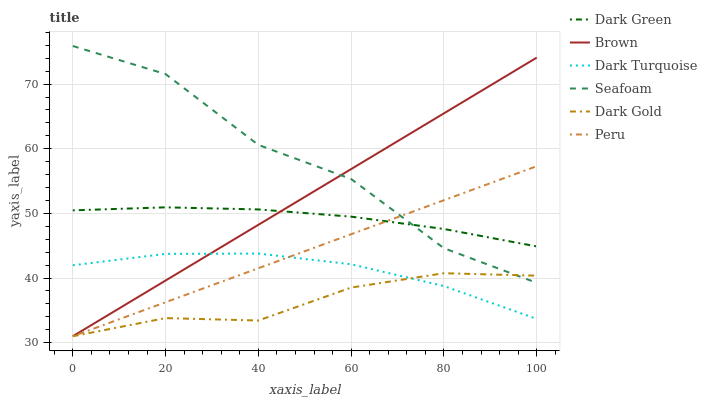Does Dark Gold have the minimum area under the curve?
Answer yes or no. Yes. Does Seafoam have the maximum area under the curve?
Answer yes or no. Yes. Does Dark Turquoise have the minimum area under the curve?
Answer yes or no. No. Does Dark Turquoise have the maximum area under the curve?
Answer yes or no. No. Is Peru the smoothest?
Answer yes or no. Yes. Is Seafoam the roughest?
Answer yes or no. Yes. Is Dark Gold the smoothest?
Answer yes or no. No. Is Dark Gold the roughest?
Answer yes or no. No. Does Brown have the lowest value?
Answer yes or no. Yes. Does Dark Turquoise have the lowest value?
Answer yes or no. No. Does Seafoam have the highest value?
Answer yes or no. Yes. Does Dark Turquoise have the highest value?
Answer yes or no. No. Is Dark Gold less than Dark Green?
Answer yes or no. Yes. Is Dark Green greater than Dark Gold?
Answer yes or no. Yes. Does Dark Gold intersect Brown?
Answer yes or no. Yes. Is Dark Gold less than Brown?
Answer yes or no. No. Is Dark Gold greater than Brown?
Answer yes or no. No. Does Dark Gold intersect Dark Green?
Answer yes or no. No. 